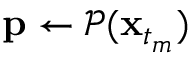<formula> <loc_0><loc_0><loc_500><loc_500>p \gets \mathcal { P } ( x _ { t _ { m } } )</formula> 